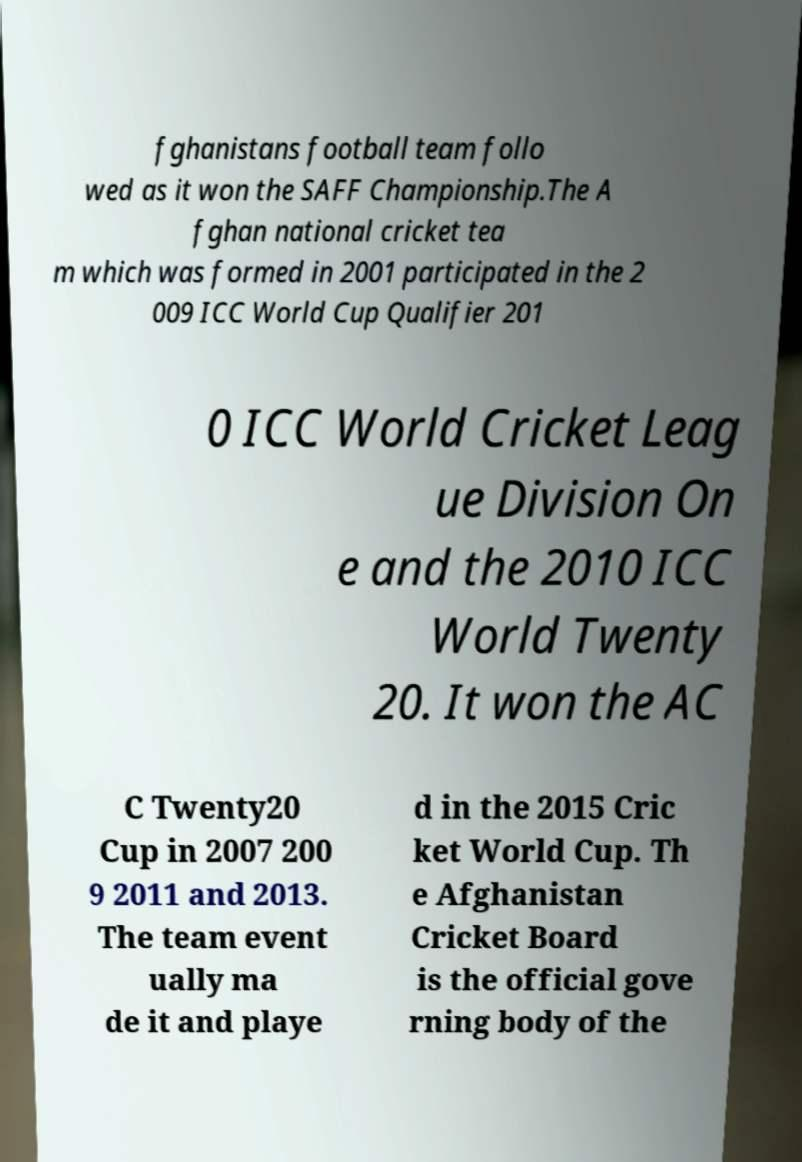Can you read and provide the text displayed in the image?This photo seems to have some interesting text. Can you extract and type it out for me? fghanistans football team follo wed as it won the SAFF Championship.The A fghan national cricket tea m which was formed in 2001 participated in the 2 009 ICC World Cup Qualifier 201 0 ICC World Cricket Leag ue Division On e and the 2010 ICC World Twenty 20. It won the AC C Twenty20 Cup in 2007 200 9 2011 and 2013. The team event ually ma de it and playe d in the 2015 Cric ket World Cup. Th e Afghanistan Cricket Board is the official gove rning body of the 